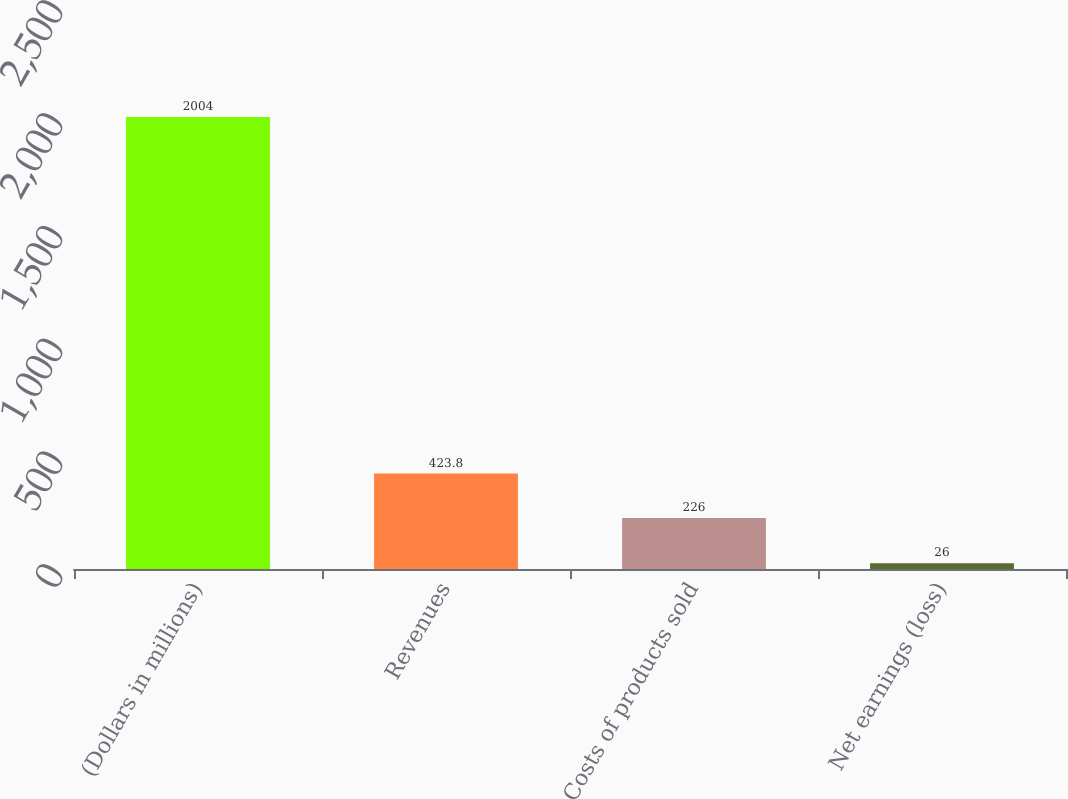<chart> <loc_0><loc_0><loc_500><loc_500><bar_chart><fcel>(Dollars in millions)<fcel>Revenues<fcel>Costs of products sold<fcel>Net earnings (loss)<nl><fcel>2004<fcel>423.8<fcel>226<fcel>26<nl></chart> 